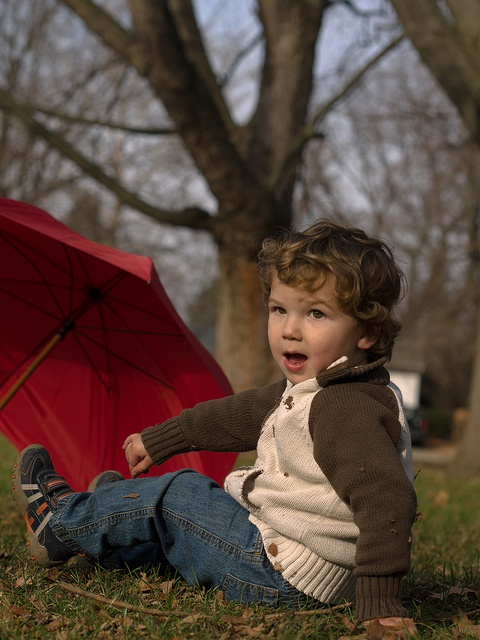Describe the objects in this image and their specific colors. I can see people in gray, black, and maroon tones and umbrella in gray, maroon, and brown tones in this image. 